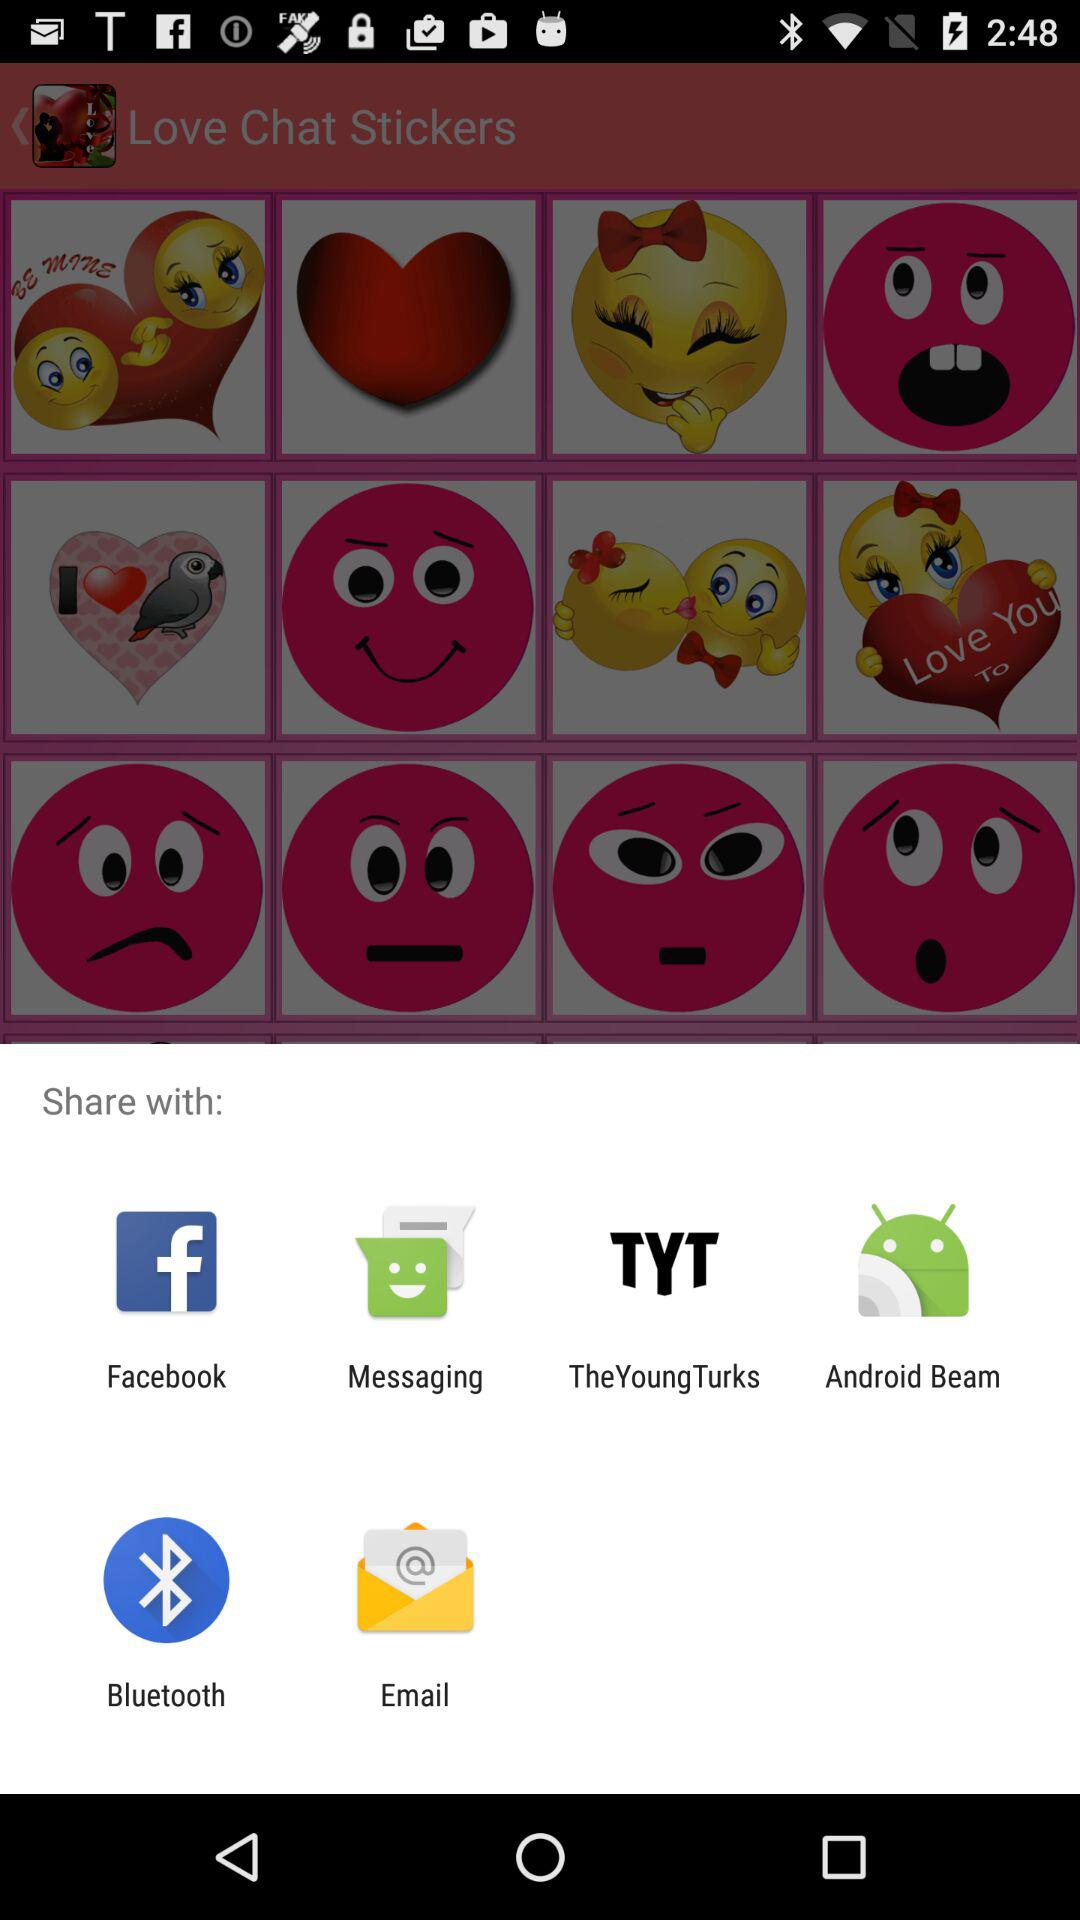What are the sharing options? The options are "Facebook", "Messaging", "TheYoungTurks", "Android Beam", "Bluetooth" and "Email". 